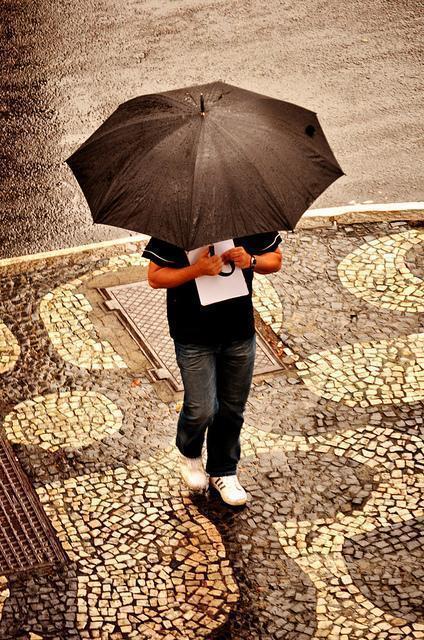What is the person wearing?
Answer the question by selecting the correct answer among the 4 following choices.
Options: Bandana, backpack, watch, crown. Watch. 